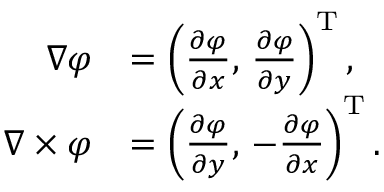<formula> <loc_0><loc_0><loc_500><loc_500>{ \begin{array} { r l } { \nabla \varphi } & { = \left ( { \frac { \partial \varphi } { \partial x } } , \, { \frac { \partial \varphi } { \partial y } } \right ) ^ { T } , } \\ { \nabla \times \varphi } & { = \left ( { \frac { \partial \varphi } { \partial y } } , \, - { \frac { \partial \varphi } { \partial x } } \right ) ^ { T } . } \end{array} }</formula> 